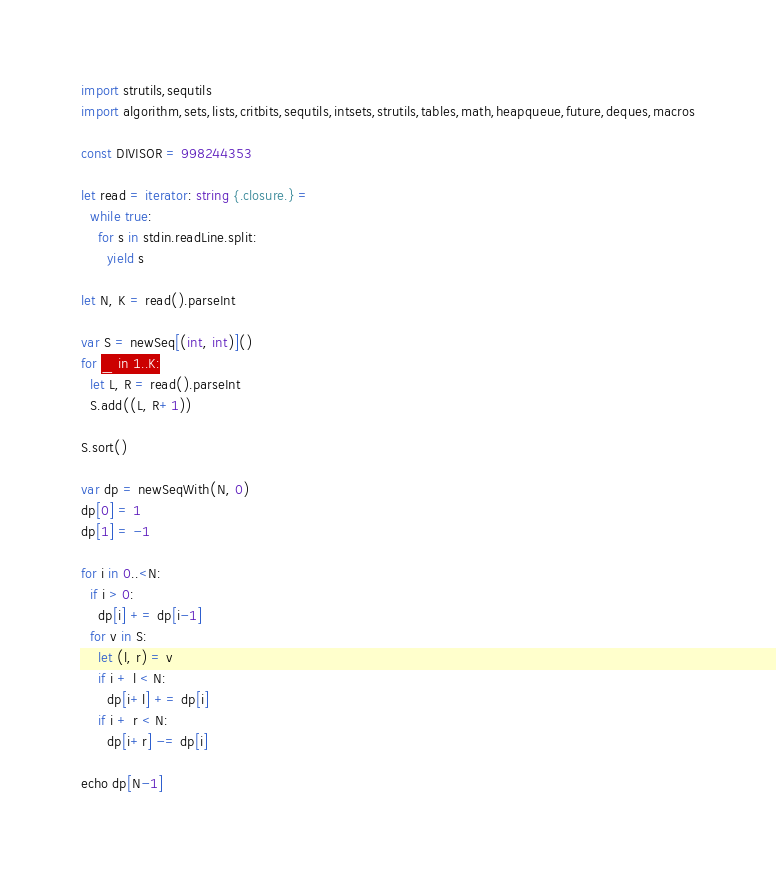Convert code to text. <code><loc_0><loc_0><loc_500><loc_500><_Nim_>import strutils,sequtils
import algorithm,sets,lists,critbits,sequtils,intsets,strutils,tables,math,heapqueue,future,deques,macros

const DIVISOR = 998244353

let read = iterator: string {.closure.} =
  while true:
    for s in stdin.readLine.split:
      yield s

let N, K = read().parseInt

var S = newSeq[(int, int)]()
for _ in 1..K:
  let L, R = read().parseInt
  S.add((L, R+1))

S.sort()

var dp = newSeqWith(N, 0)
dp[0] = 1
dp[1] = -1

for i in 0..<N:
  if i > 0:
    dp[i] += dp[i-1]
  for v in S:
    let (l, r) = v
    if i + l < N:
      dp[i+l] += dp[i]
    if i + r < N:
      dp[i+r] -= dp[i]

echo dp[N-1]
</code> 